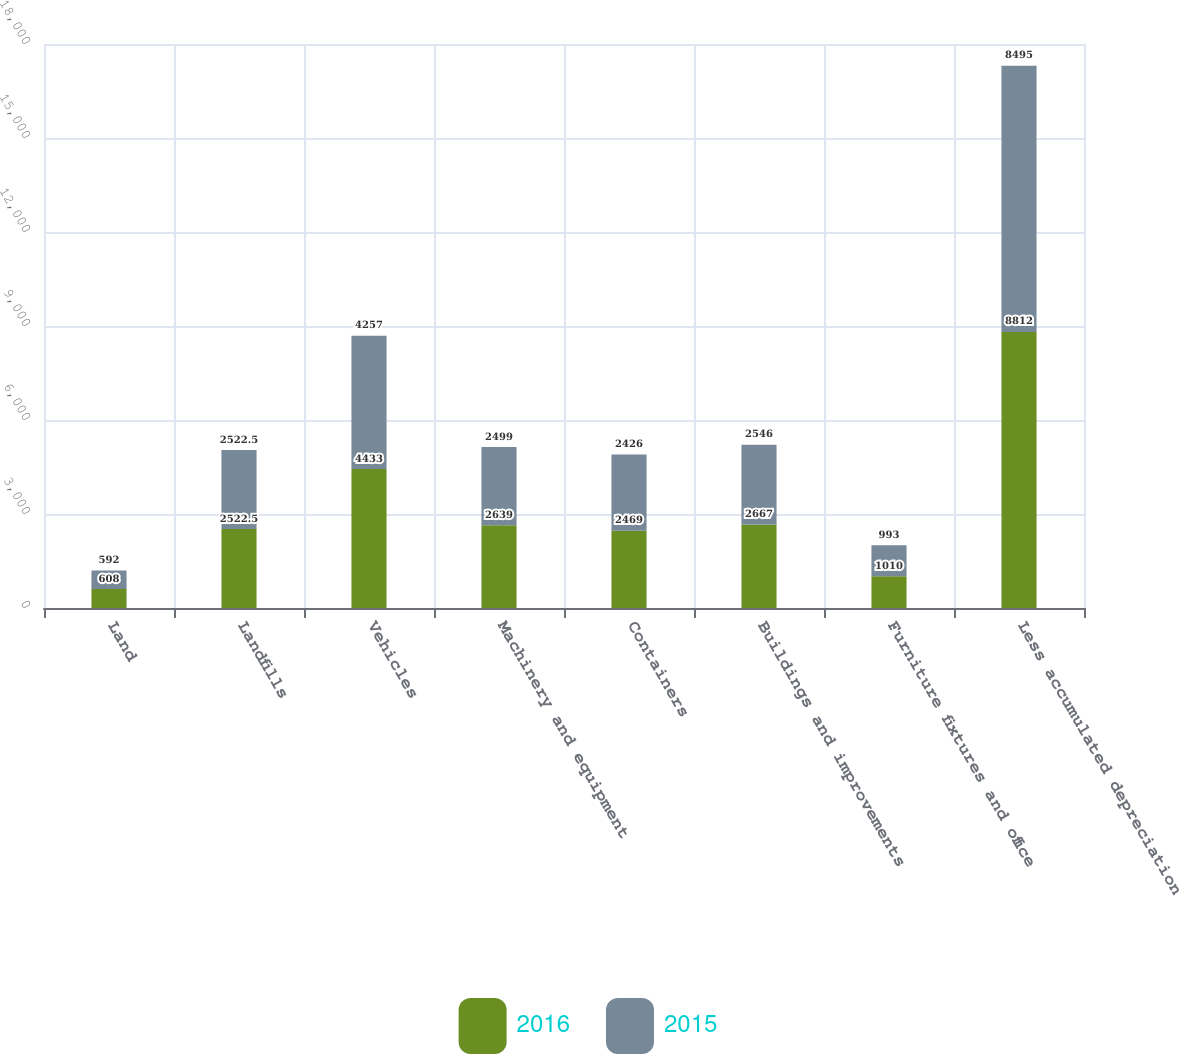Convert chart. <chart><loc_0><loc_0><loc_500><loc_500><stacked_bar_chart><ecel><fcel>Land<fcel>Landfills<fcel>Vehicles<fcel>Machinery and equipment<fcel>Containers<fcel>Buildings and improvements<fcel>Furniture fixtures and office<fcel>Less accumulated depreciation<nl><fcel>2016<fcel>608<fcel>2522.5<fcel>4433<fcel>2639<fcel>2469<fcel>2667<fcel>1010<fcel>8812<nl><fcel>2015<fcel>592<fcel>2522.5<fcel>4257<fcel>2499<fcel>2426<fcel>2546<fcel>993<fcel>8495<nl></chart> 